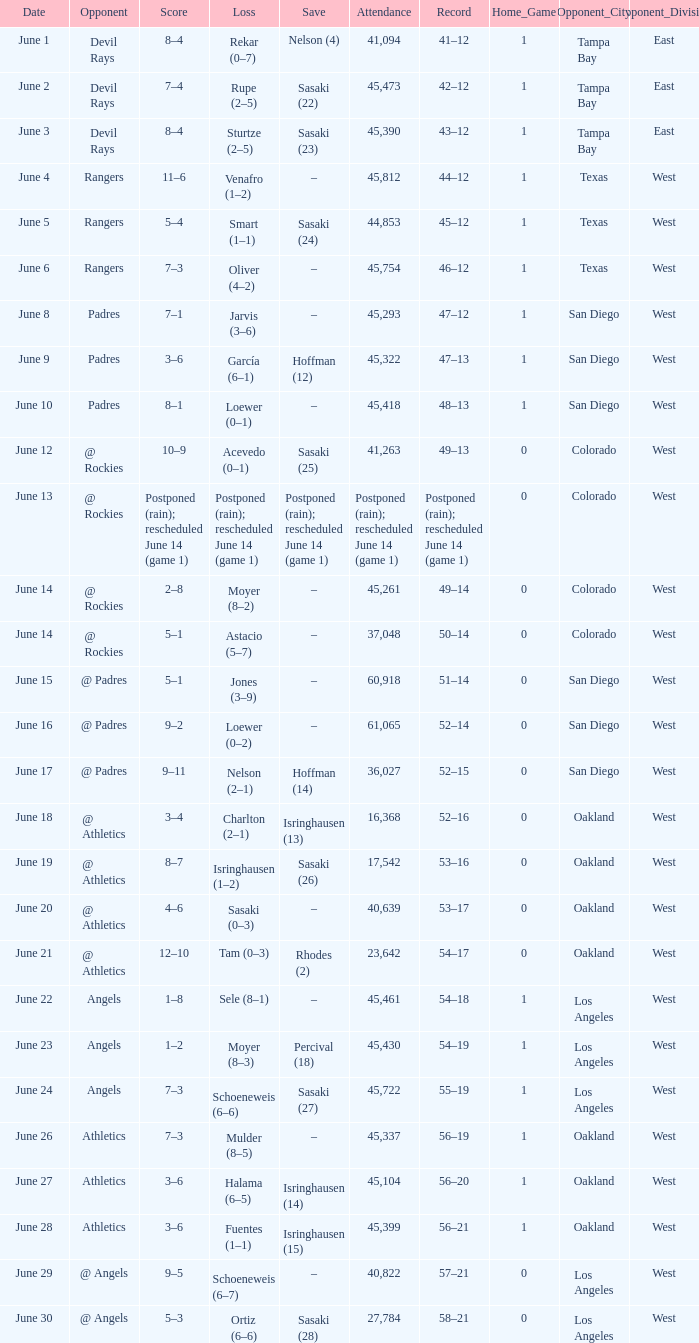What was the date of the Mariners game when they had a record of 53–17? June 20. 